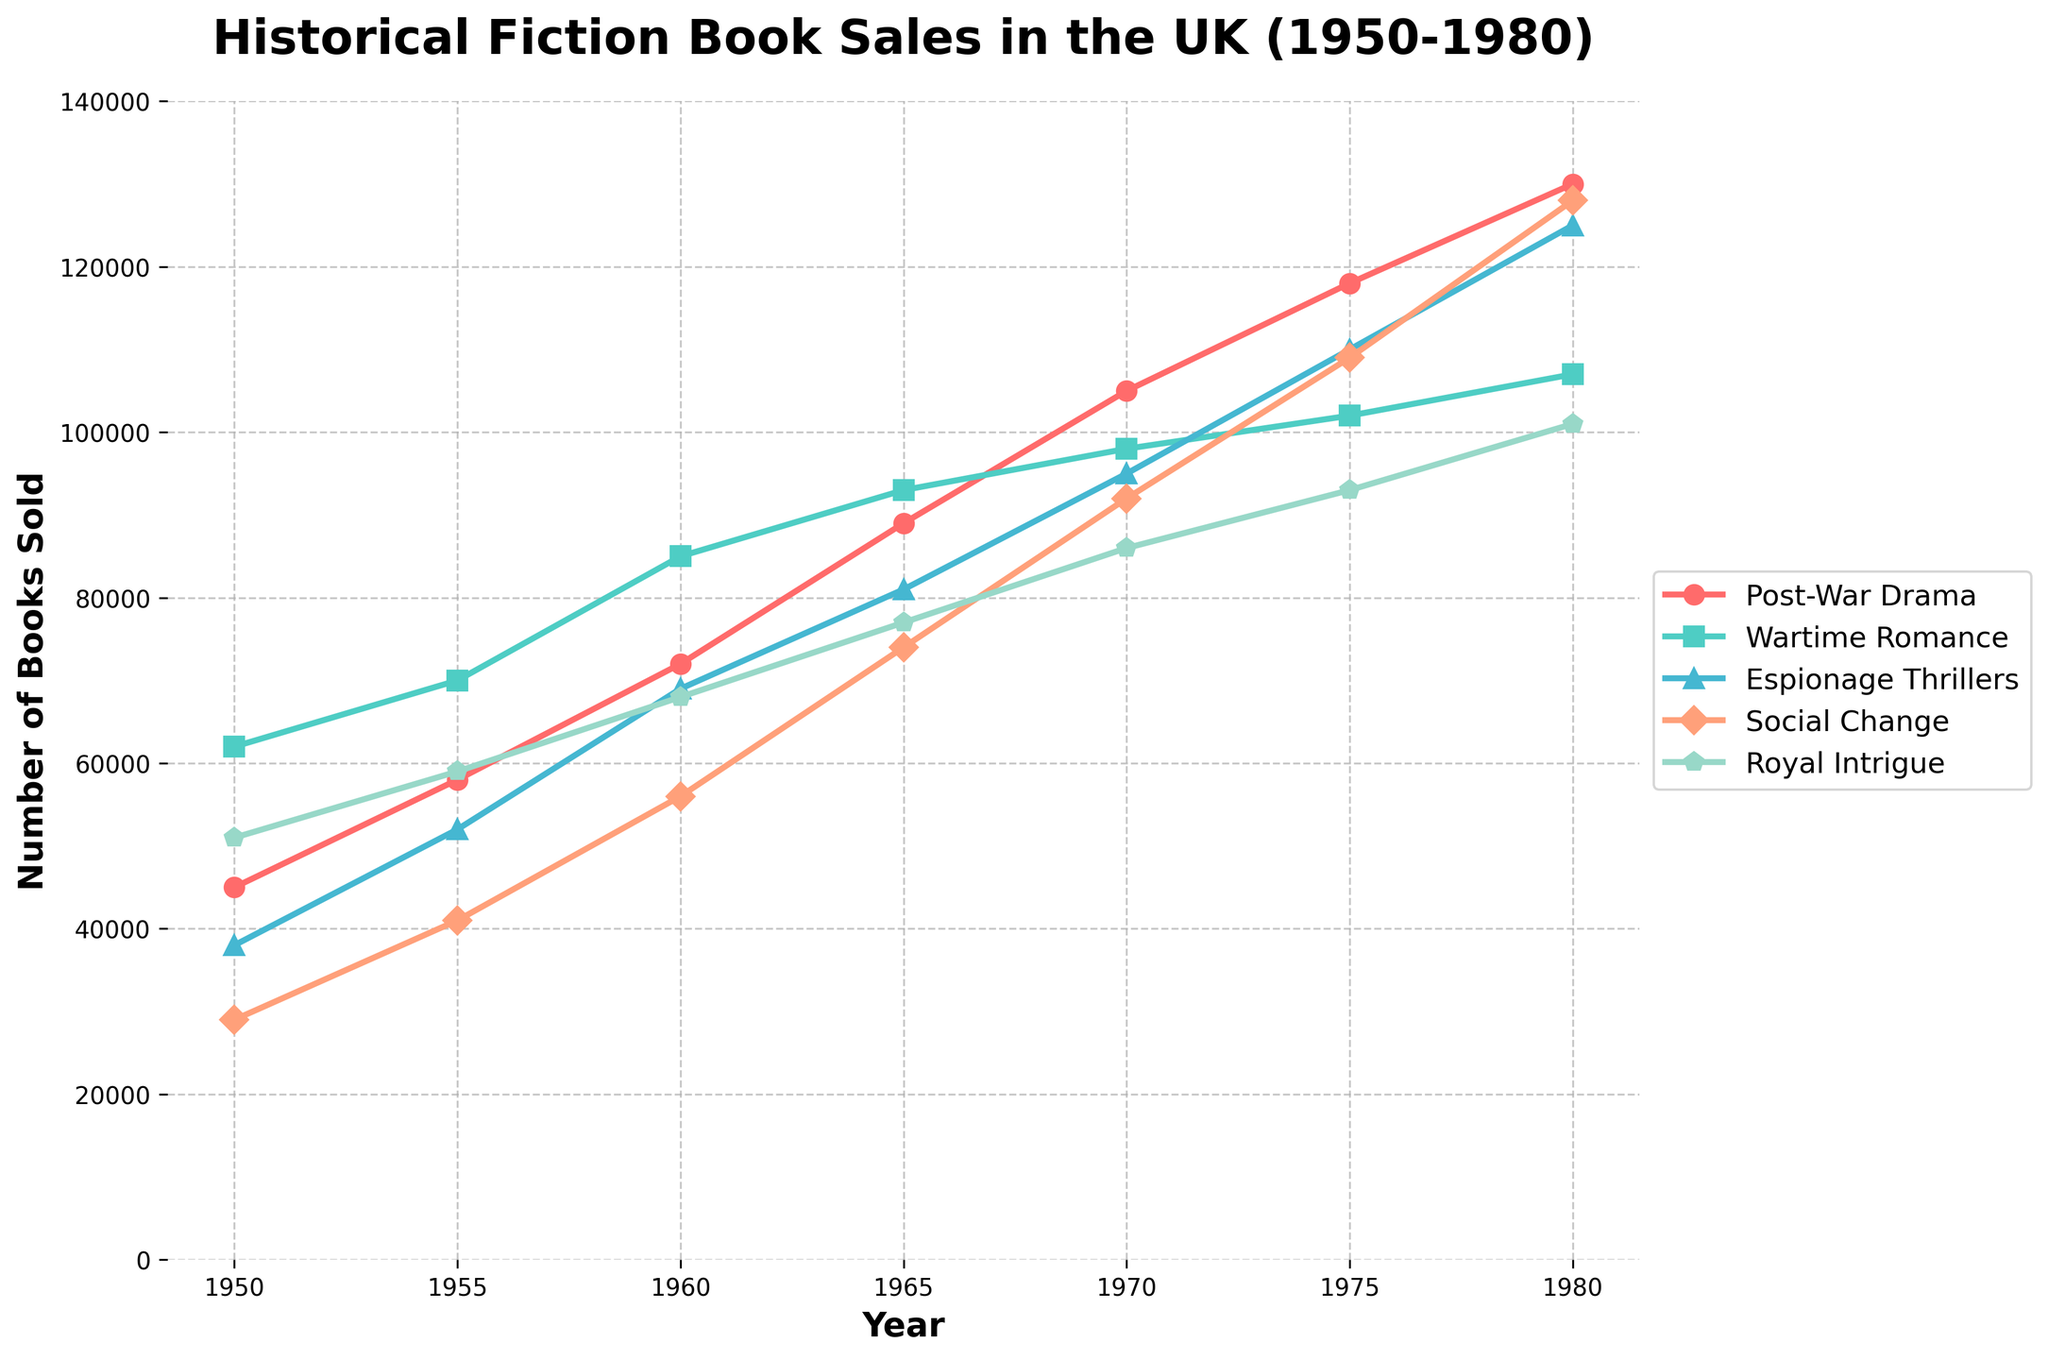how did the sales of Post-War Drama books grow from 1950 to 1980? From the figure, locate the sales value for Post-War Drama in 1950, which is 45,000, and in 1980, which is 130,000. Subtract the 1950 value from the 1980 value to find the growth in sales: 130,000 - 45,000 = 85,000
Answer: 85,000 Which subgenre had the highest sales in 1965? From the figure, find the sales values for each subgenre in 1965. Post-War Drama: 89,000, Wartime Romance: 93,000, Espionage Thrillers: 81,000, Social Change: 74,000, and Royal Intrigue: 77,000. The highest value is for Wartime Romance with 93,000 sales
Answer: Wartime Romance In which year did Social Change books first surpass 100,000 in sales? From the figure, track the sales of Social Change books over the years. The sales first surpass 100,000 in 1980 when the sales reach 128,000
Answer: 1980 Compare the sales of Wartime Romance and Royal Intrigue books in 1970. Which had higher sales and by how much? From the figure, locate the sales in 1970 for Wartime Romance, which is 98,000, and for Royal Intrigue, which is 86,000. Subtract the sales of Royal Intrigue from Wartime Romance: 98,000 - 86,000 = 12,000. Wartime Romance had higher sales by 12,000
Answer: Wartime Romance by 12,000 What is the average sales of Espionage Thrillers from 1950 to 1980? From the figure, add the sales values for Espionage Thrillers from 1950 (38,000), 1955 (52,000), 1960 (69,000), 1965 (81,000), 1970 (95,000), 1975 (110,000), and 1980 (125,000). Sum: 38,000 + 52,000 + 69,000 + 81,000 + 95,000 + 110,000 + 125,000 = 570,000. Divide by the number of years (7): 570,000 / 7 = ~81,429
Answer: ~81,429 Which subgenre showed consistent growth every year from 1950 to 1980? From the figure, analyze the sales trends of each subgenre across the years. Post-War Drama, Wartime Romance, Espionage Thrillers, Social Change, and Royal Intrigue each showed year-on-year growth trends, but Espionage Thrillers is consistently increasing without any drops
Answer: Espionage Thrillers Identify the subgenre with the least sales increase from 1950 to 1980. Calculate the increase for each subgenre by subtracting 1950 sales from 1980 sales: Post-War Drama (130,000 - 45,000 = 85,000), Wartime Romance (107,000 - 62,000 = 45,000), Espionage Thrillers (125,000 - 38,000 = 87,000), Social Change (128,000 - 29,000 = 99,000), Royal Intrigue (101,000 - 51,000 = 50,000). The least increase is for Wartime Romance with 45,000
Answer: Wartime Romance 